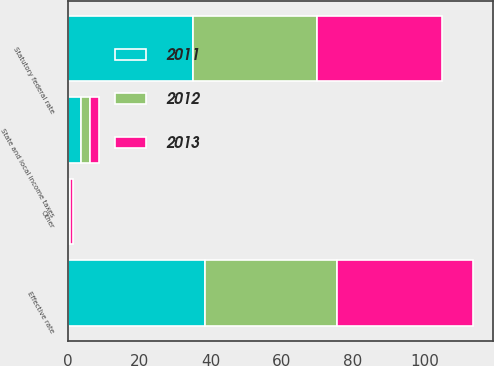Convert chart to OTSL. <chart><loc_0><loc_0><loc_500><loc_500><stacked_bar_chart><ecel><fcel>Statutory federal rate<fcel>State and local income taxes<fcel>Other<fcel>Effective rate<nl><fcel>2012<fcel>35<fcel>2.6<fcel>0.4<fcel>37.2<nl><fcel>2013<fcel>35<fcel>2.4<fcel>0.7<fcel>38.1<nl><fcel>2011<fcel>35<fcel>3.7<fcel>0.3<fcel>38.4<nl></chart> 